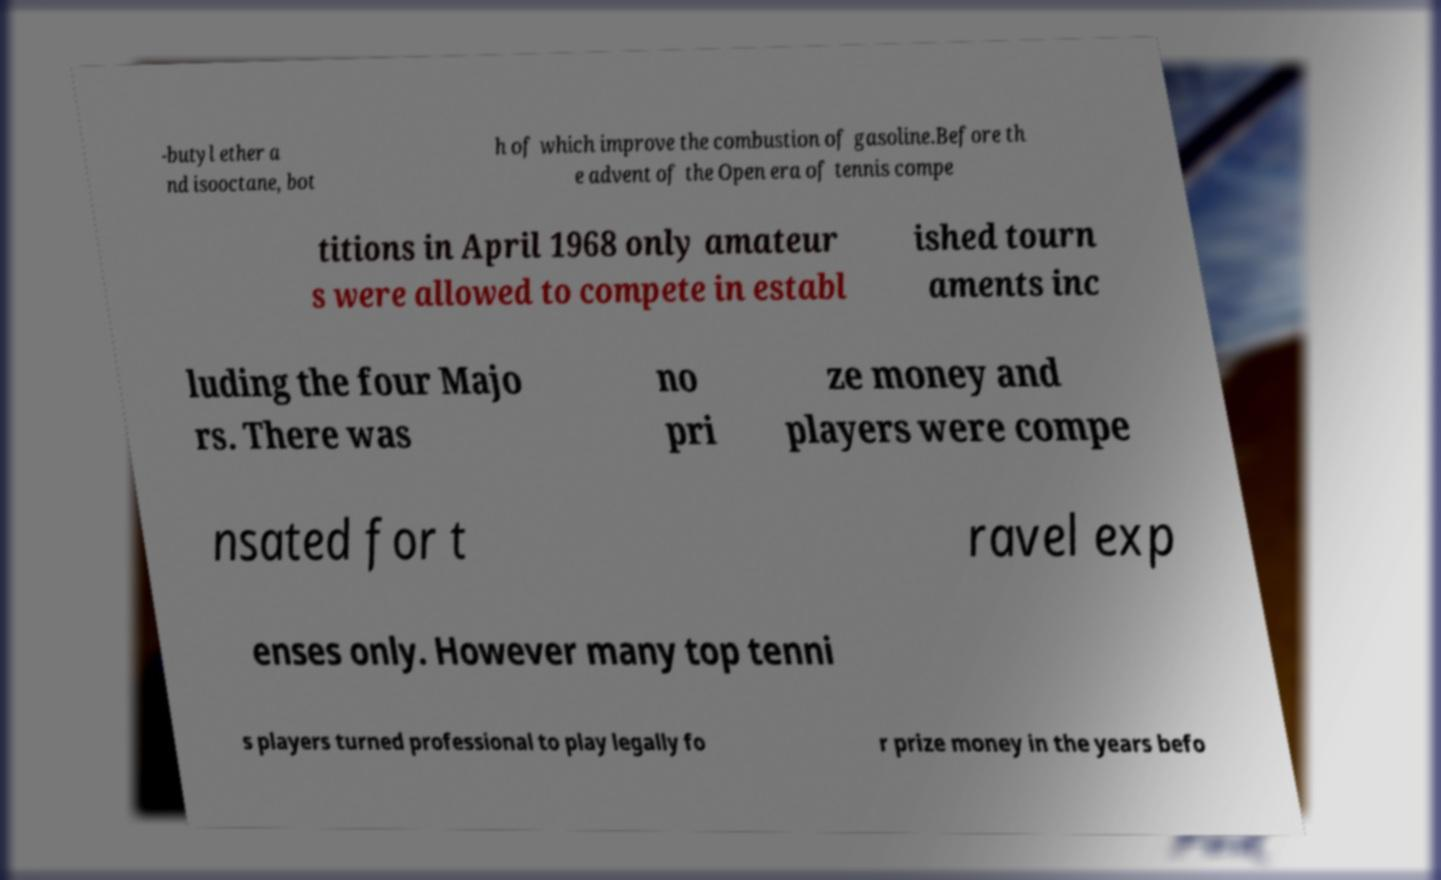What messages or text are displayed in this image? I need them in a readable, typed format. -butyl ether a nd isooctane, bot h of which improve the combustion of gasoline.Before th e advent of the Open era of tennis compe titions in April 1968 only amateur s were allowed to compete in establ ished tourn aments inc luding the four Majo rs. There was no pri ze money and players were compe nsated for t ravel exp enses only. However many top tenni s players turned professional to play legally fo r prize money in the years befo 